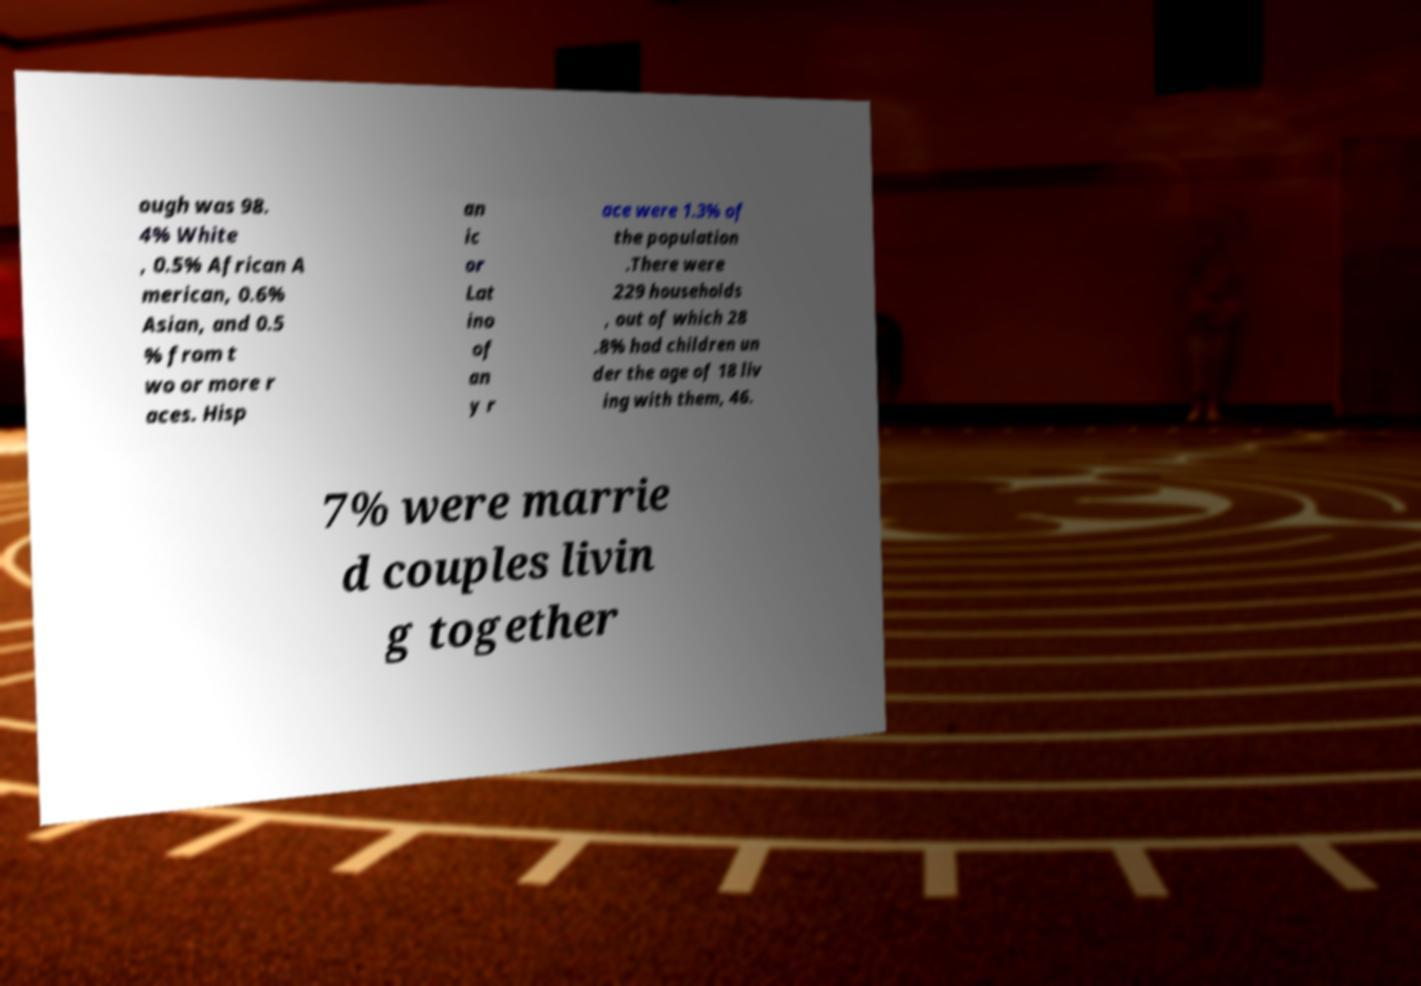Can you accurately transcribe the text from the provided image for me? ough was 98. 4% White , 0.5% African A merican, 0.6% Asian, and 0.5 % from t wo or more r aces. Hisp an ic or Lat ino of an y r ace were 1.3% of the population .There were 229 households , out of which 28 .8% had children un der the age of 18 liv ing with them, 46. 7% were marrie d couples livin g together 